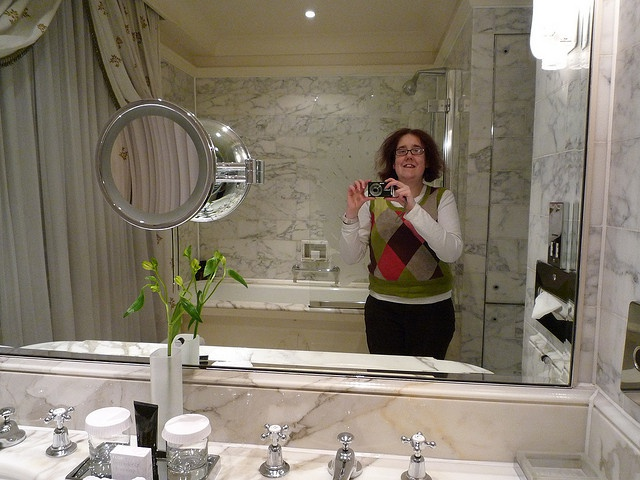Describe the objects in this image and their specific colors. I can see people in gray, black, olive, and maroon tones, sink in gray, lightgray, and darkgray tones, sink in gray, lightgray, and darkgray tones, cup in gray, lightgray, and darkgray tones, and potted plant in gray, darkgray, darkgreen, and olive tones in this image. 